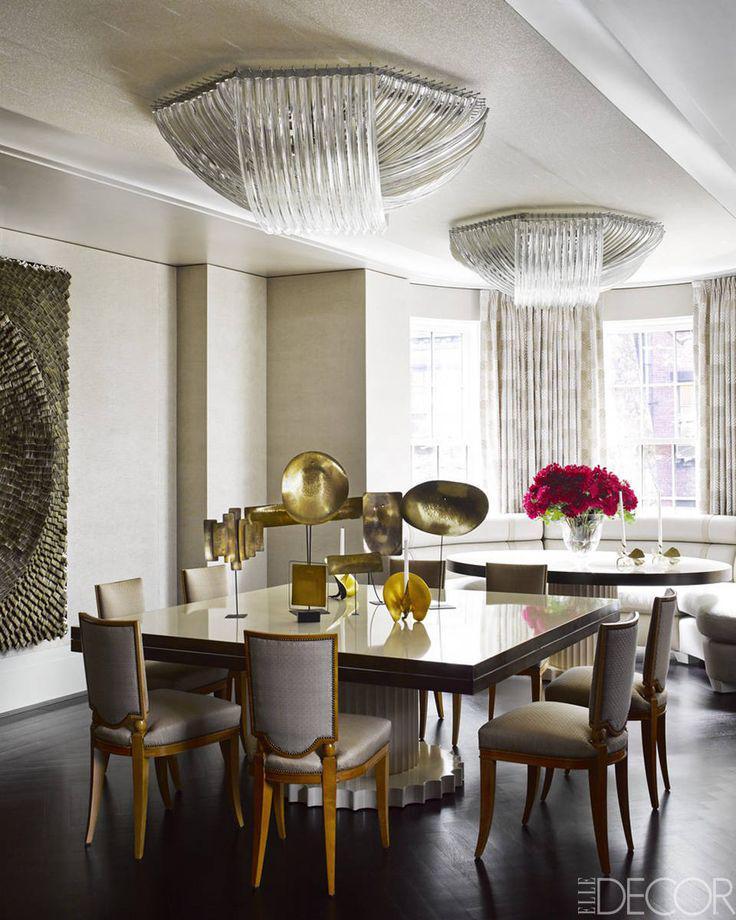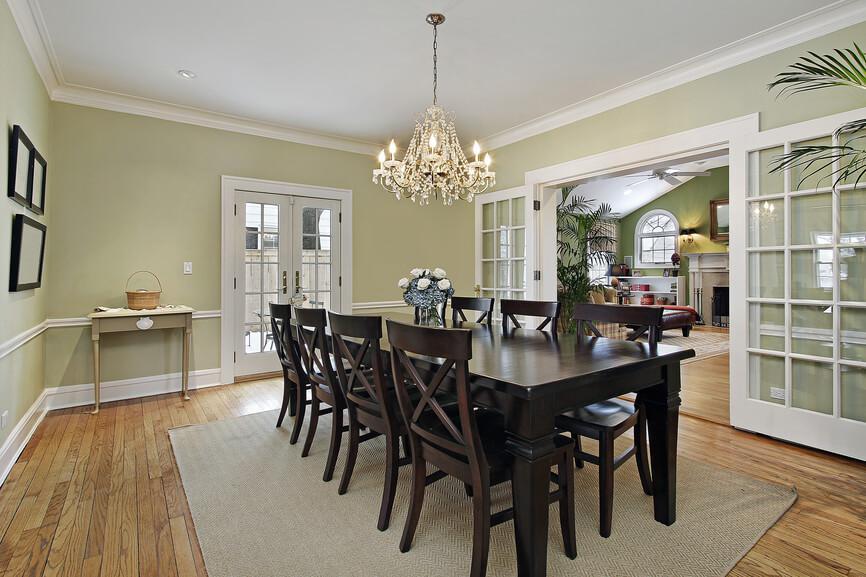The first image is the image on the left, the second image is the image on the right. Evaluate the accuracy of this statement regarding the images: "The right image shows two chandleliers suspended over a single table, and six chairs with curved legs are positioned by the table.". Is it true? Answer yes or no. No. The first image is the image on the left, the second image is the image on the right. For the images displayed, is the sentence "In at least one image there are two parallel kitchen table sets with at least one painting behind them" factually correct? Answer yes or no. No. 